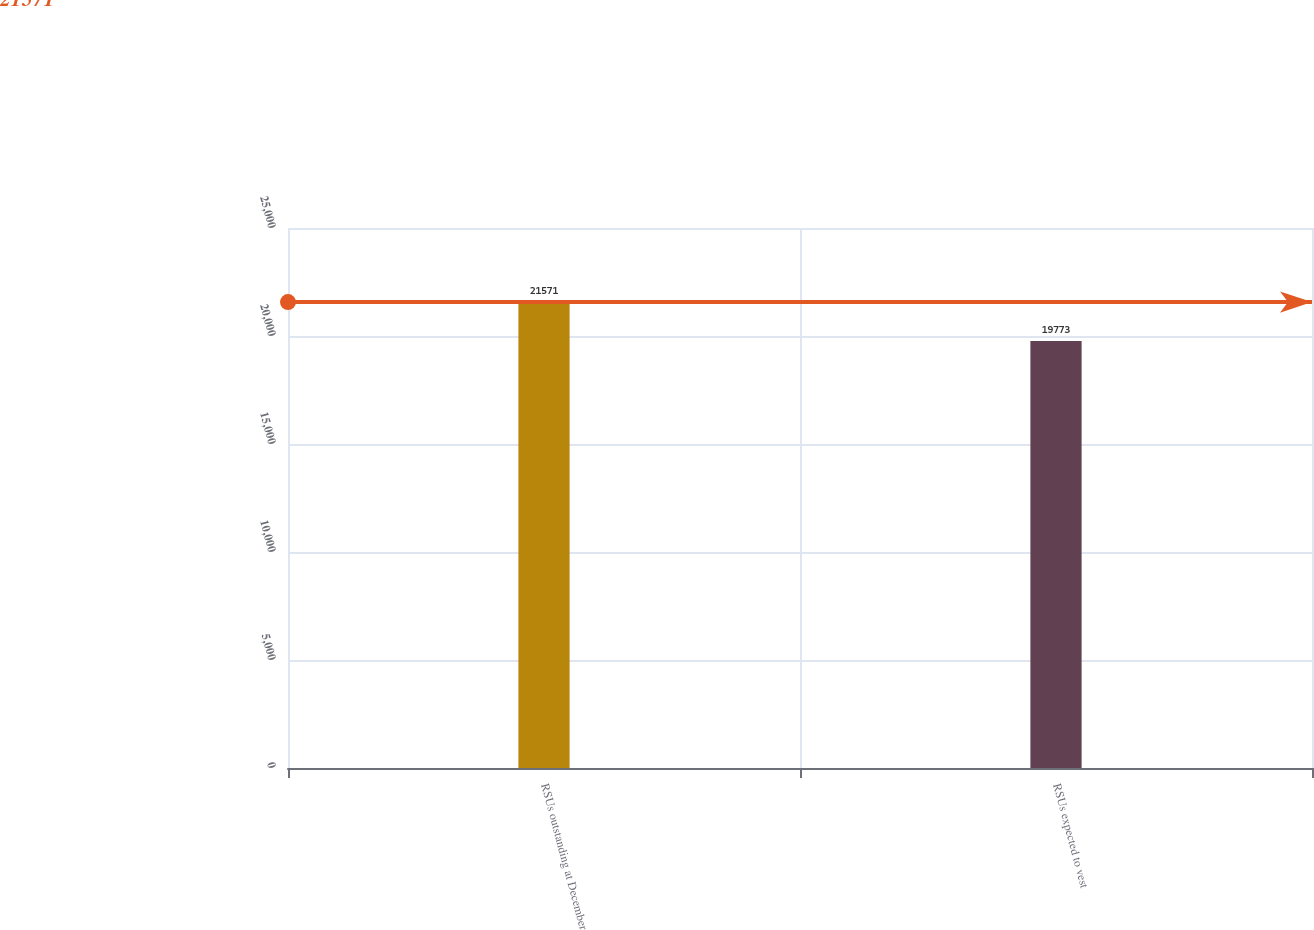Convert chart to OTSL. <chart><loc_0><loc_0><loc_500><loc_500><bar_chart><fcel>RSUs outstanding at December<fcel>RSUs expected to vest<nl><fcel>21571<fcel>19773<nl></chart> 